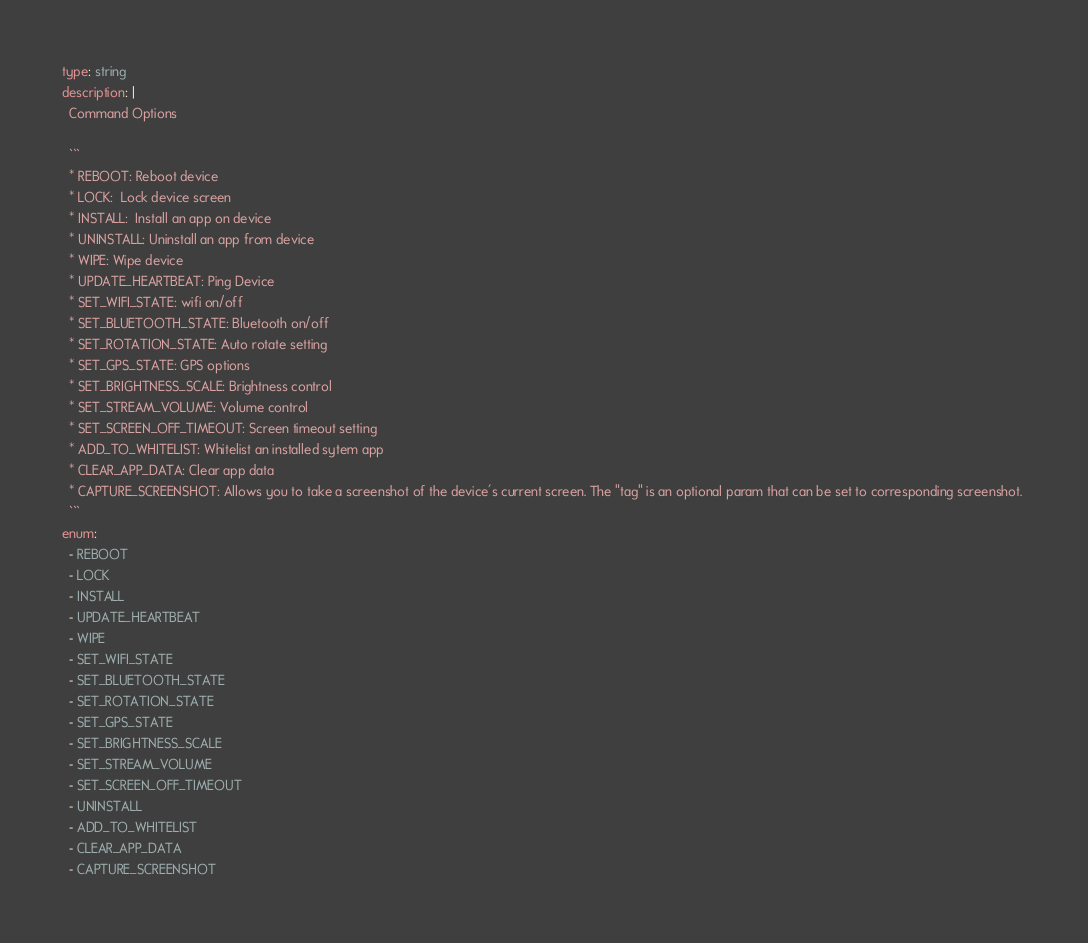<code> <loc_0><loc_0><loc_500><loc_500><_YAML_>type: string
description: |
  Command Options

  ```
  * REBOOT: Reboot device
  * LOCK:  Lock device screen
  * INSTALL:  Install an app on device
  * UNINSTALL: Uninstall an app from device
  * WIPE: Wipe device
  * UPDATE_HEARTBEAT: Ping Device
  * SET_WIFI_STATE: wifi on/off
  * SET_BLUETOOTH_STATE: Bluetooth on/off
  * SET_ROTATION_STATE: Auto rotate setting
  * SET_GPS_STATE: GPS options
  * SET_BRIGHTNESS_SCALE: Brightness control
  * SET_STREAM_VOLUME: Volume control
  * SET_SCREEN_OFF_TIMEOUT: Screen timeout setting
  * ADD_TO_WHITELIST: Whitelist an installed sytem app
  * CLEAR_APP_DATA: Clear app data
  * CAPTURE_SCREENSHOT: Allows you to take a screenshot of the device's current screen. The "tag" is an optional param that can be set to corresponding screenshot. 
  ```
enum:
  - REBOOT
  - LOCK
  - INSTALL
  - UPDATE_HEARTBEAT
  - WIPE
  - SET_WIFI_STATE
  - SET_BLUETOOTH_STATE
  - SET_ROTATION_STATE
  - SET_GPS_STATE
  - SET_BRIGHTNESS_SCALE
  - SET_STREAM_VOLUME
  - SET_SCREEN_OFF_TIMEOUT
  - UNINSTALL
  - ADD_TO_WHITELIST
  - CLEAR_APP_DATA
  - CAPTURE_SCREENSHOT  
</code> 